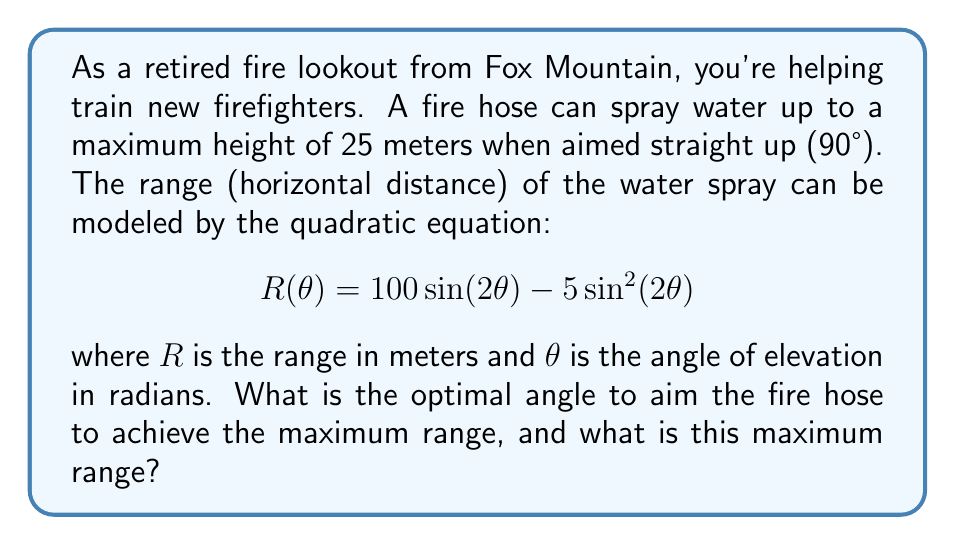Provide a solution to this math problem. To find the optimal angle for maximum range, we need to find the maximum of the quadratic function $R(θ)$.

1) First, let's simplify the equation using the trigonometric double angle formula:
   $\sin(2θ) = 2\sin(θ)\cos(θ)$
   
   $$R(θ) = 100(2\sin(θ)\cos(θ)) - 5(2\sin(θ)\cos(θ))^2$$
   $$R(θ) = 200\sin(θ)\cos(θ) - 20\sin^2(θ)\cos^2(θ)$$

2) To find the maximum, we need to find where the derivative equals zero:
   
   $$\frac{dR}{dθ} = 200(\cos^2(θ) - \sin^2(θ)) - 80\sin(θ)\cos(θ)(\cos^2(θ) - \sin^2(θ))$$
   $$= 200(\cos^2(θ) - \sin^2(θ))(1 - 0.4\sin(θ)\cos(θ))$$

3) Setting this equal to zero:
   
   $200(\cos^2(θ) - \sin^2(θ))(1 - 0.4\sin(θ)\cos(θ)) = 0$

4) This is satisfied when:
   $\cos^2(θ) - \sin^2(θ) = 0$ or $1 - 0.4\sin(θ)\cos(θ) = 0$

5) From the first equation:
   $\cos^2(θ) = \sin^2(θ)$
   $\cos(θ) = \sin(θ)$
   $θ = \frac{\pi}{4} = 45°$

6) This angle satisfies the second equation as well:
   $1 - 0.4\sin(\frac{\pi}{4})\cos(\frac{\pi}{4}) = 1 - 0.4(\frac{\sqrt{2}}{2})(\frac{\sqrt{2}}{2}) = 1 - 0.2 = 0.8 \neq 0$

7) Therefore, the optimal angle is $45°$ or $\frac{\pi}{4}$ radians.

8) To find the maximum range, we substitute this angle back into the original equation:

   $$R(\frac{\pi}{4}) = 100 \sin(\frac{\pi}{2}) - 5 \sin^2(\frac{\pi}{2})$$
   $$= 100(1) - 5(1)^2 = 95$$

Thus, the maximum range is 95 meters.
Answer: The optimal angle to aim the fire hose for maximum range is 45° or $\frac{\pi}{4}$ radians, and the maximum range achieved at this angle is 95 meters. 